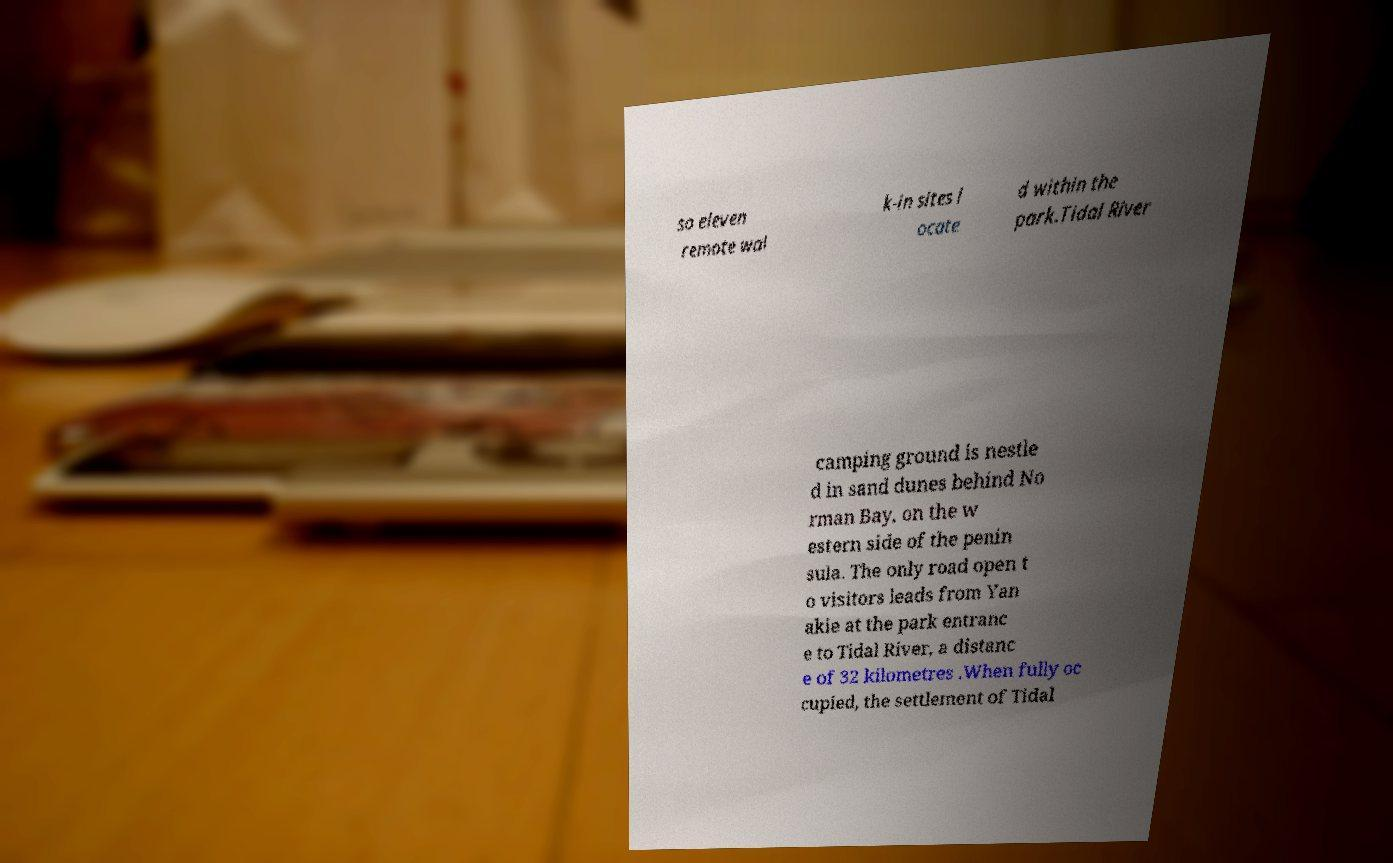Can you read and provide the text displayed in the image?This photo seems to have some interesting text. Can you extract and type it out for me? so eleven remote wal k-in sites l ocate d within the park.Tidal River camping ground is nestle d in sand dunes behind No rman Bay, on the w estern side of the penin sula. The only road open t o visitors leads from Yan akie at the park entranc e to Tidal River, a distanc e of 32 kilometres .When fully oc cupied, the settlement of Tidal 